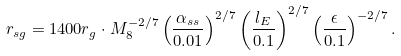<formula> <loc_0><loc_0><loc_500><loc_500>r _ { s g } = 1 4 0 0 r _ { g } \cdot M _ { 8 } ^ { - 2 / 7 } \left ( \frac { \alpha _ { s s } } { 0 . 0 1 } \right ) ^ { 2 / 7 } \left ( \frac { l _ { E } } { 0 . 1 } \right ) ^ { 2 / 7 } \left ( \frac { \epsilon } { 0 . 1 } \right ) ^ { - 2 / 7 } .</formula> 